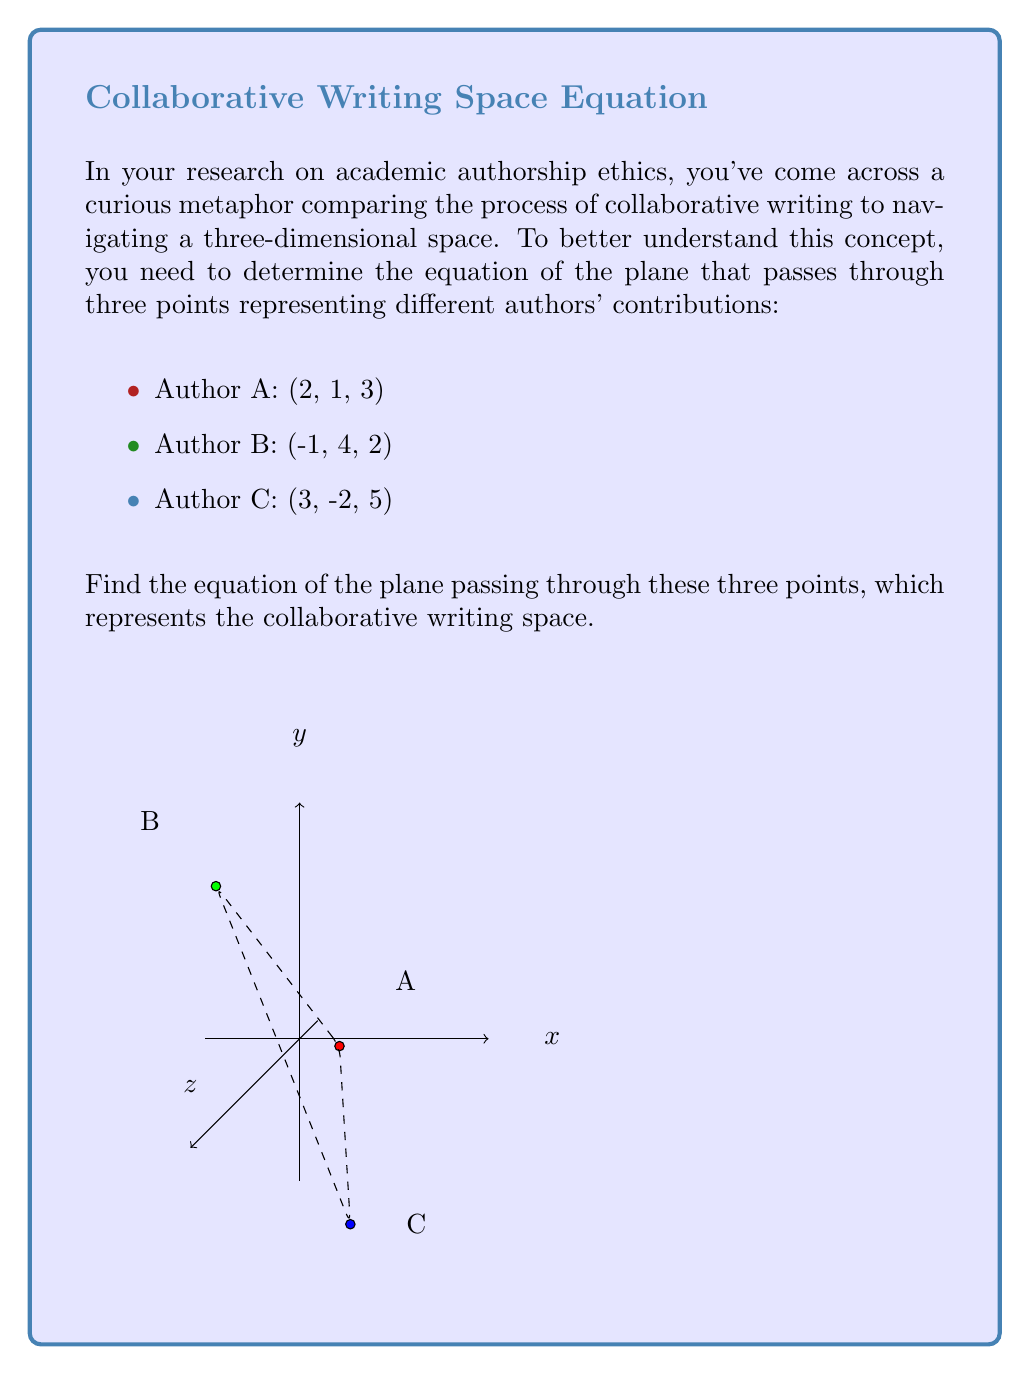Could you help me with this problem? Let's approach this step-by-step:

1) To find the equation of a plane passing through three non-collinear points, we can use the general form of a plane equation:

   $$ Ax + By + Cz + D = 0 $$

   where $(A, B, C)$ is a normal vector to the plane.

2) To find the normal vector, we can use the cross product of two vectors on the plane. Let's create two vectors:

   $\vec{v} = B - A = (-1-2, 4-1, 2-3) = (-3, 3, -1)$
   $\vec{w} = C - A = (3-2, -2-1, 5-3) = (1, -3, 2)$

3) Now, let's calculate the cross product $\vec{n} = \vec{v} \times \vec{w}$:

   $$ \vec{n} = \begin{vmatrix} 
   i & j & k \\
   -3 & 3 & -1 \\
   1 & -3 & 2
   \end{vmatrix} = (9-(-3))i + ((-6)-(-1))j + (9-3)k $$

   $$ \vec{n} = 12i - 5j + 6k $$

4) So, our normal vector is $(12, -5, 6)$, and our plane equation is:

   $$ 12x - 5y + 6z + D = 0 $$

5) To find $D$, we can substitute the coordinates of any of the given points. Let's use point A (2, 1, 3):

   $$ 12(2) - 5(1) + 6(3) + D = 0 $$
   $$ 24 - 5 + 18 + D = 0 $$
   $$ 37 + D = 0 $$
   $$ D = -37 $$

6) Therefore, the final equation of the plane is:

   $$ 12x - 5y + 6z - 37 = 0 $$

This equation represents the collaborative writing space in your metaphor, where each point corresponds to an author's contribution.
Answer: $$ 12x - 5y + 6z - 37 = 0 $$ 